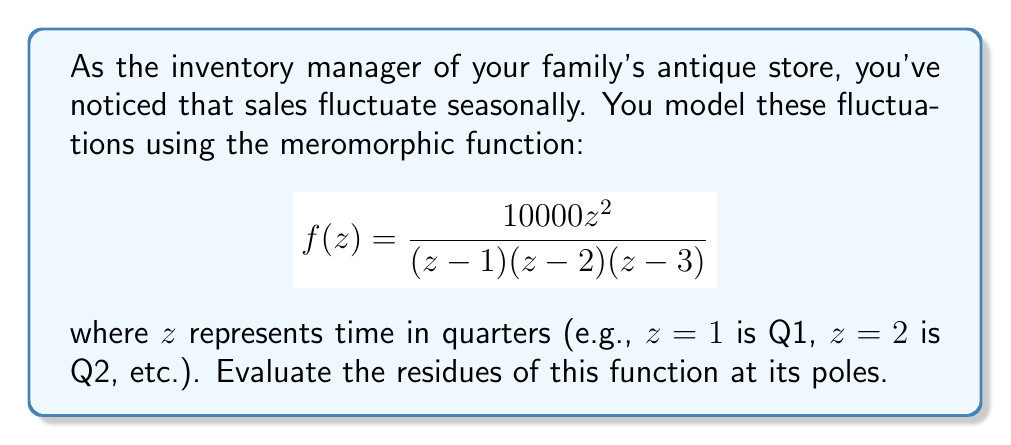Teach me how to tackle this problem. To evaluate the residues of this meromorphic function, we'll follow these steps:

1) First, identify the poles of the function. The poles are at $z=1$, $z=2$, and $z=3$.

2) For each pole, we'll use the formula for the residue of a simple pole:

   $$\text{Res}(f,a) = \lim_{z \to a} (z-a)f(z)$$

3) For $z=1$:
   $$\begin{align*}
   \text{Res}(f,1) &= \lim_{z \to 1} (z-1)\frac{10000z^2}{(z-1)(z-2)(z-3)} \\
   &= \lim_{z \to 1} \frac{10000z^2}{(z-2)(z-3)} \\
   &= \frac{10000(1)^2}{(1-2)(1-3)} \\
   &= \frac{10000}{2} = 5000
   \end{align*}$$

4) For $z=2$:
   $$\begin{align*}
   \text{Res}(f,2) &= \lim_{z \to 2} (z-2)\frac{10000z^2}{(z-1)(z-2)(z-3)} \\
   &= \lim_{z \to 2} \frac{10000z^2}{(z-1)(z-3)} \\
   &= \frac{10000(2)^2}{(2-1)(2-3)} \\
   &= -40000
   \end{align*}$$

5) For $z=3$:
   $$\begin{align*}
   \text{Res}(f,3) &= \lim_{z \to 3} (z-3)\frac{10000z^2}{(z-1)(z-2)(z-3)} \\
   &= \lim_{z \to 3} \frac{10000z^2}{(z-1)(z-2)} \\
   &= \frac{10000(3)^2}{(3-1)(3-2)} \\
   &= 45000
   \end{align*}$$

Therefore, the residues at the poles $z=1$, $z=2$, and $z=3$ are 5000, -40000, and 45000 respectively.
Answer: $\text{Res}(f,1) = 5000$, $\text{Res}(f,2) = -40000$, $\text{Res}(f,3) = 45000$ 